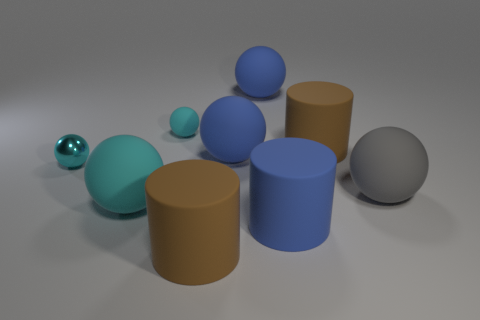What number of matte cylinders are on the left side of the shiny ball?
Ensure brevity in your answer.  0. Is there a tiny green sphere made of the same material as the big cyan thing?
Your response must be concise. No. There is a cyan ball that is the same size as the gray object; what is its material?
Your answer should be compact. Rubber. Are the large cyan sphere and the large gray sphere made of the same material?
Your answer should be compact. Yes. What number of things are small objects or cylinders?
Your answer should be very brief. 5. There is a matte thing in front of the big blue cylinder; what is its shape?
Keep it short and to the point. Cylinder. What is the color of the tiny object that is made of the same material as the blue cylinder?
Your response must be concise. Cyan. What is the material of the other tiny object that is the same shape as the cyan metallic object?
Offer a very short reply. Rubber. The tiny cyan metal thing is what shape?
Your answer should be very brief. Sphere. What material is the ball that is both in front of the metallic thing and on the left side of the tiny cyan rubber sphere?
Make the answer very short. Rubber. 